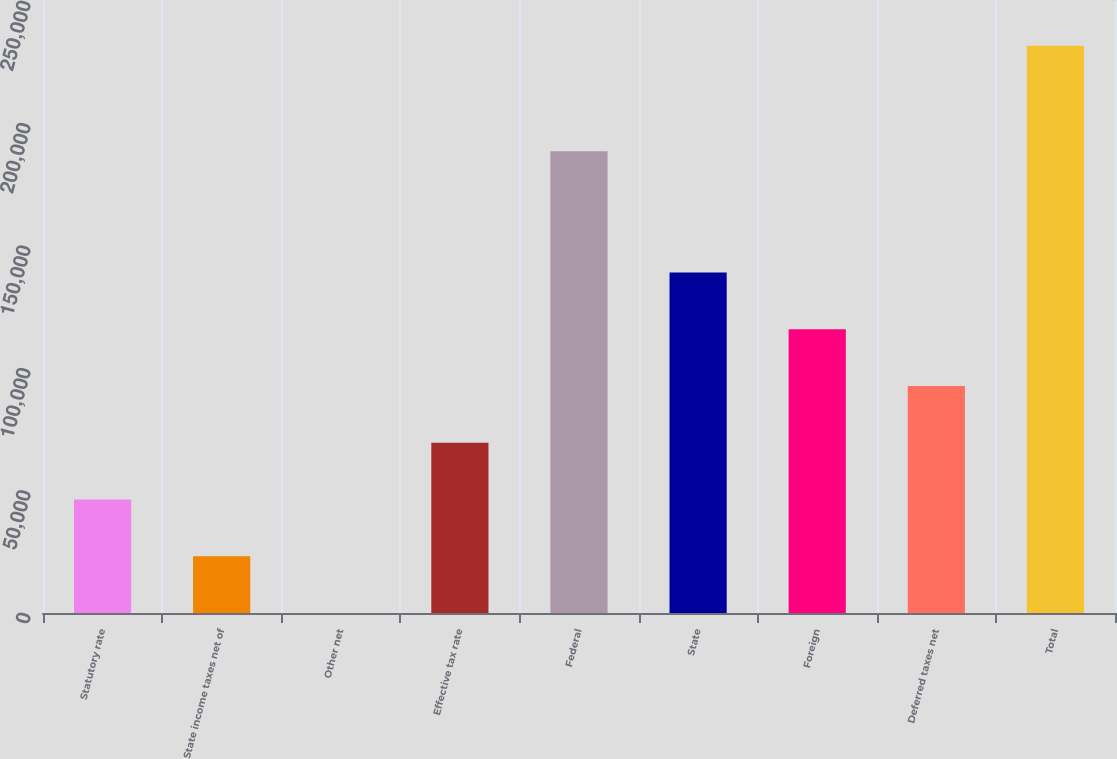<chart> <loc_0><loc_0><loc_500><loc_500><bar_chart><fcel>Statutory rate<fcel>State income taxes net of<fcel>Other net<fcel>Effective tax rate<fcel>Federal<fcel>State<fcel>Foreign<fcel>Deferred taxes net<fcel>Total<nl><fcel>46351.8<fcel>23176.5<fcel>1.2<fcel>69527<fcel>188647<fcel>139053<fcel>115878<fcel>92702.3<fcel>231754<nl></chart> 